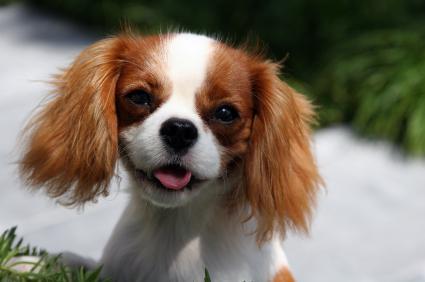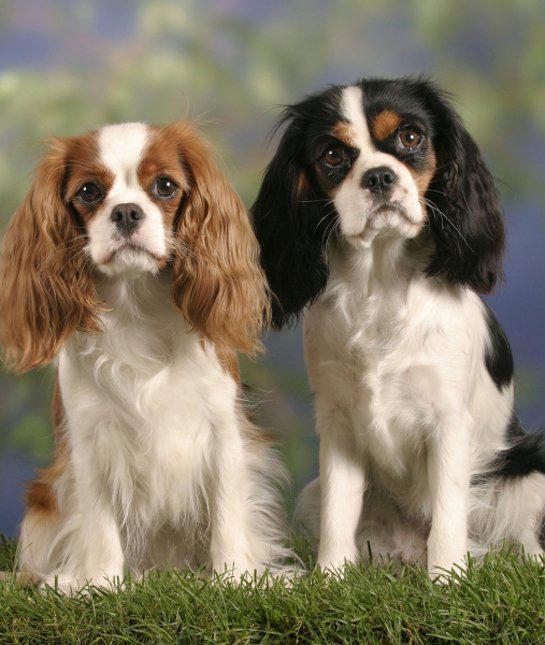The first image is the image on the left, the second image is the image on the right. Evaluate the accuracy of this statement regarding the images: "One image depicts exactly two dogs side by side on grass.". Is it true? Answer yes or no. Yes. 